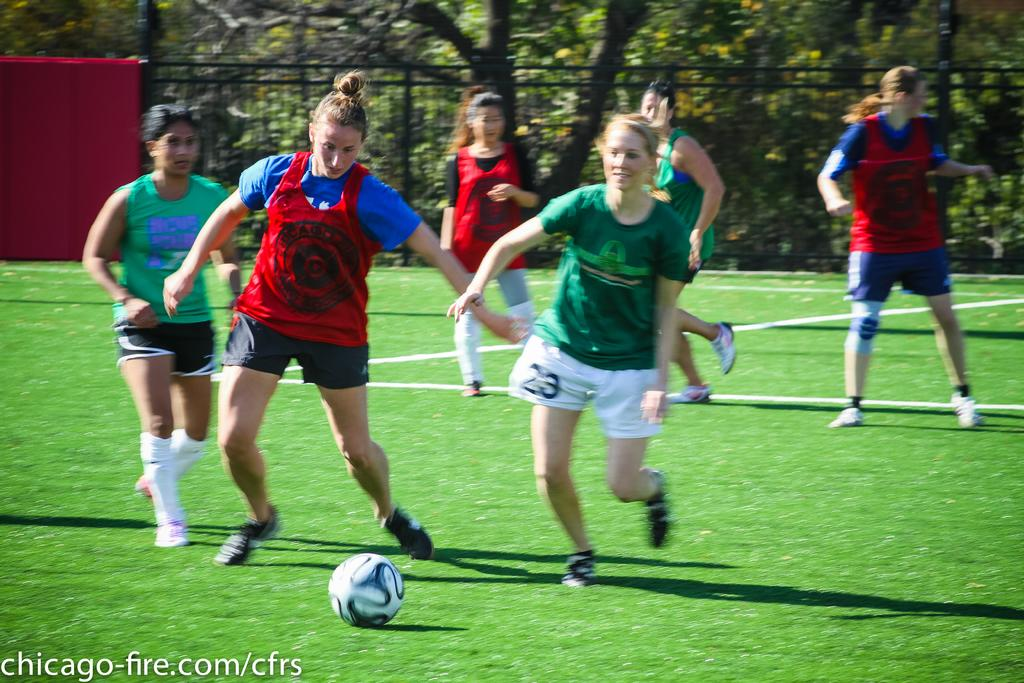<image>
Give a short and clear explanation of the subsequent image. A group of girls playing soccer that have their picture on the chicago-fire.com website. 